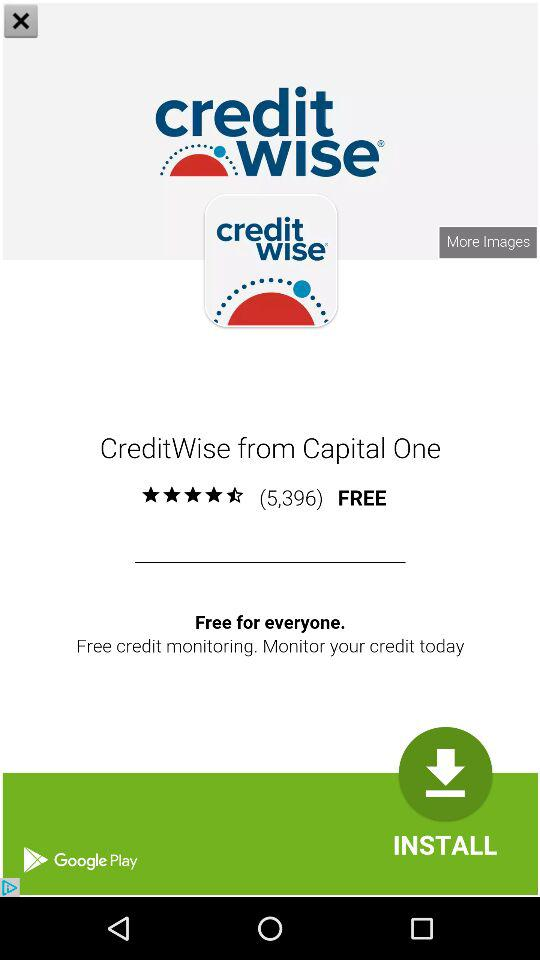How many people have reviewed the application? The application has been reviewed by 5,396 people. 